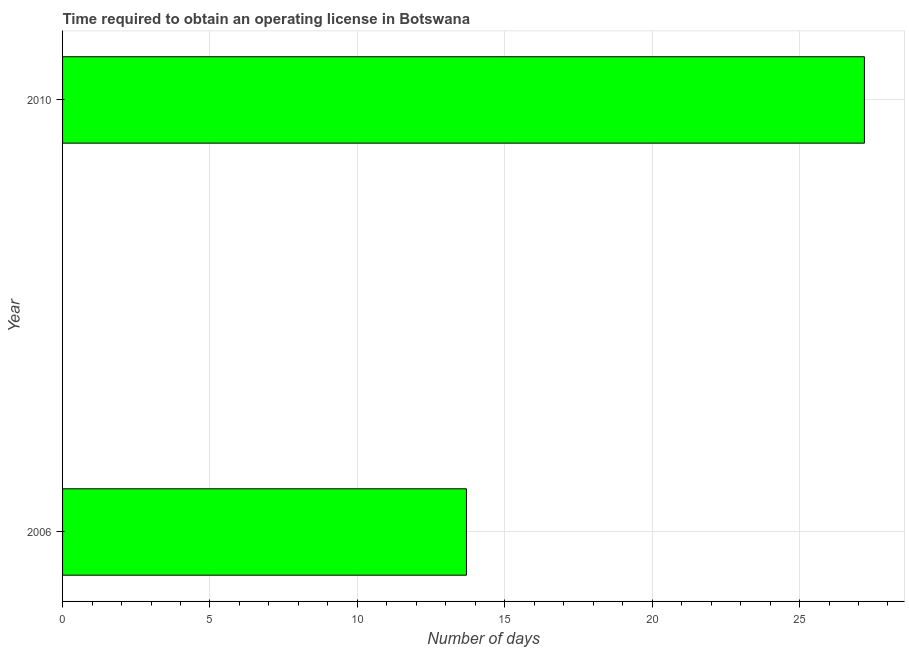What is the title of the graph?
Provide a short and direct response. Time required to obtain an operating license in Botswana. What is the label or title of the X-axis?
Your answer should be compact. Number of days. Across all years, what is the maximum number of days to obtain operating license?
Ensure brevity in your answer.  27.2. Across all years, what is the minimum number of days to obtain operating license?
Ensure brevity in your answer.  13.7. In which year was the number of days to obtain operating license minimum?
Give a very brief answer. 2006. What is the sum of the number of days to obtain operating license?
Give a very brief answer. 40.9. What is the average number of days to obtain operating license per year?
Offer a terse response. 20.45. What is the median number of days to obtain operating license?
Make the answer very short. 20.45. What is the ratio of the number of days to obtain operating license in 2006 to that in 2010?
Your answer should be compact. 0.5. Is the number of days to obtain operating license in 2006 less than that in 2010?
Offer a terse response. Yes. How many bars are there?
Your answer should be compact. 2. Are all the bars in the graph horizontal?
Your response must be concise. Yes. What is the Number of days in 2010?
Provide a short and direct response. 27.2. What is the difference between the Number of days in 2006 and 2010?
Provide a short and direct response. -13.5. What is the ratio of the Number of days in 2006 to that in 2010?
Your answer should be very brief. 0.5. 